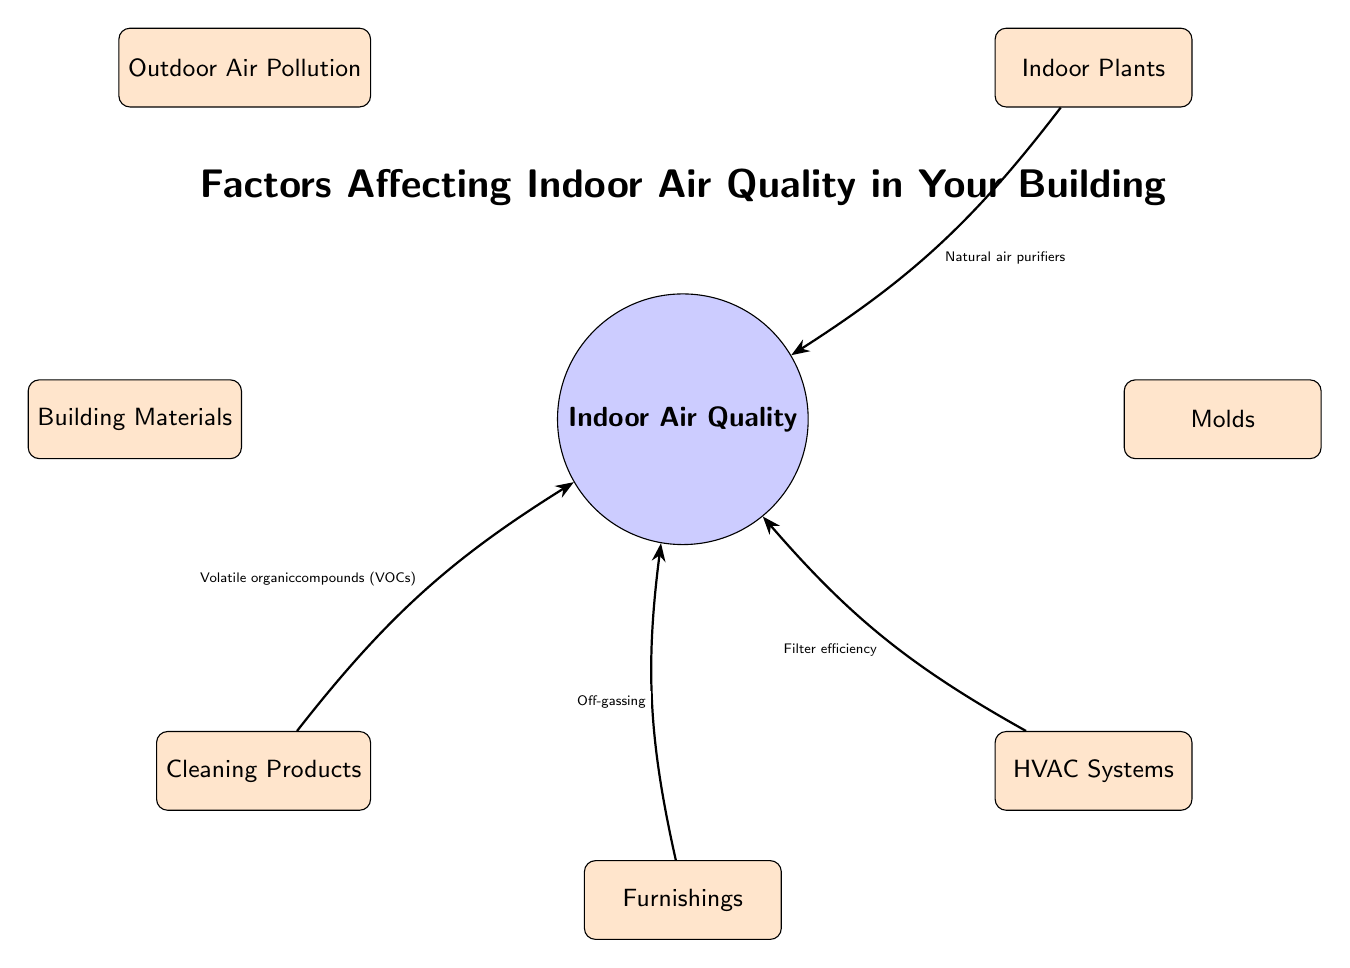What are the sources of indoor air quality listed in the diagram? The diagram lists seven sources that affect indoor air quality: outdoor air pollution, building materials, cleaning products, furnishings, HVAC systems, molds, and indoor plants.
Answer: Outdoor air pollution, building materials, cleaning products, furnishings, HVAC systems, molds, indoor plants How many nodes are shown in the diagram? The diagram highlights a total of eight nodes: one central node representing indoor air quality and seven sources surrounding it.
Answer: 8 What factor is associated with outdoor air pollution? The edge from the outdoor air pollution node states that it is associated with vehicle emissions and industrial pollutants, which contribute to indoor air quality.
Answer: Vehicle emissions, industrial pollutants Which source is linked to VOCs? The cleaning products node in the diagram indicates that it is linked to volatile organic compounds (VOCs), which affect indoor air quality.
Answer: Cleaning products What natural benefit do indoor plants provide according to the diagram? The indoor plants node specifies that they serve as natural air purifiers, improving the overall indoor air quality in the building.
Answer: Natural air purifiers Which source includes asbestos and formaldehyde? The building materials node of the diagram indicates that it includes asbestos and formaldehyde as factors affecting indoor air quality.
Answer: Building materials What relationship exists between HVAC systems and indoor air quality? The diagram shows that HVAC systems are linked to the efficiency of their filters, which can significantly affect indoor air quality in the building.
Answer: Filter efficiency How many sources are linked to indoor air quality through off-gassing? The diagram indicates that furnishings are associated with off-gassing, relating it as one of the sources to indoor air quality. Therefore, there is one source linked to off-gassing.
Answer: 1 